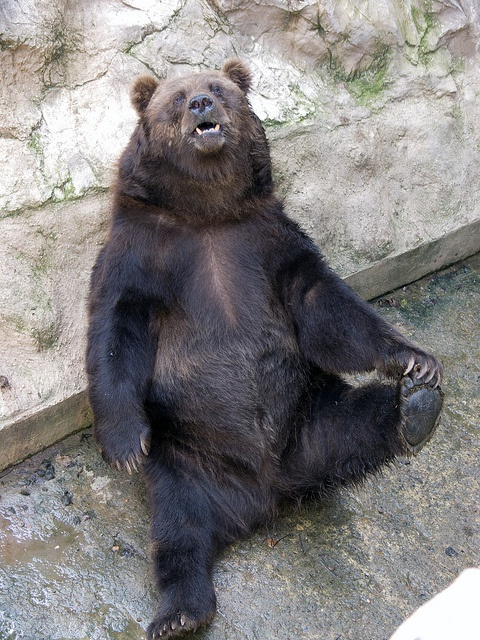Describe the objects in this image and their specific colors. I can see a bear in darkgray, black, and gray tones in this image. 